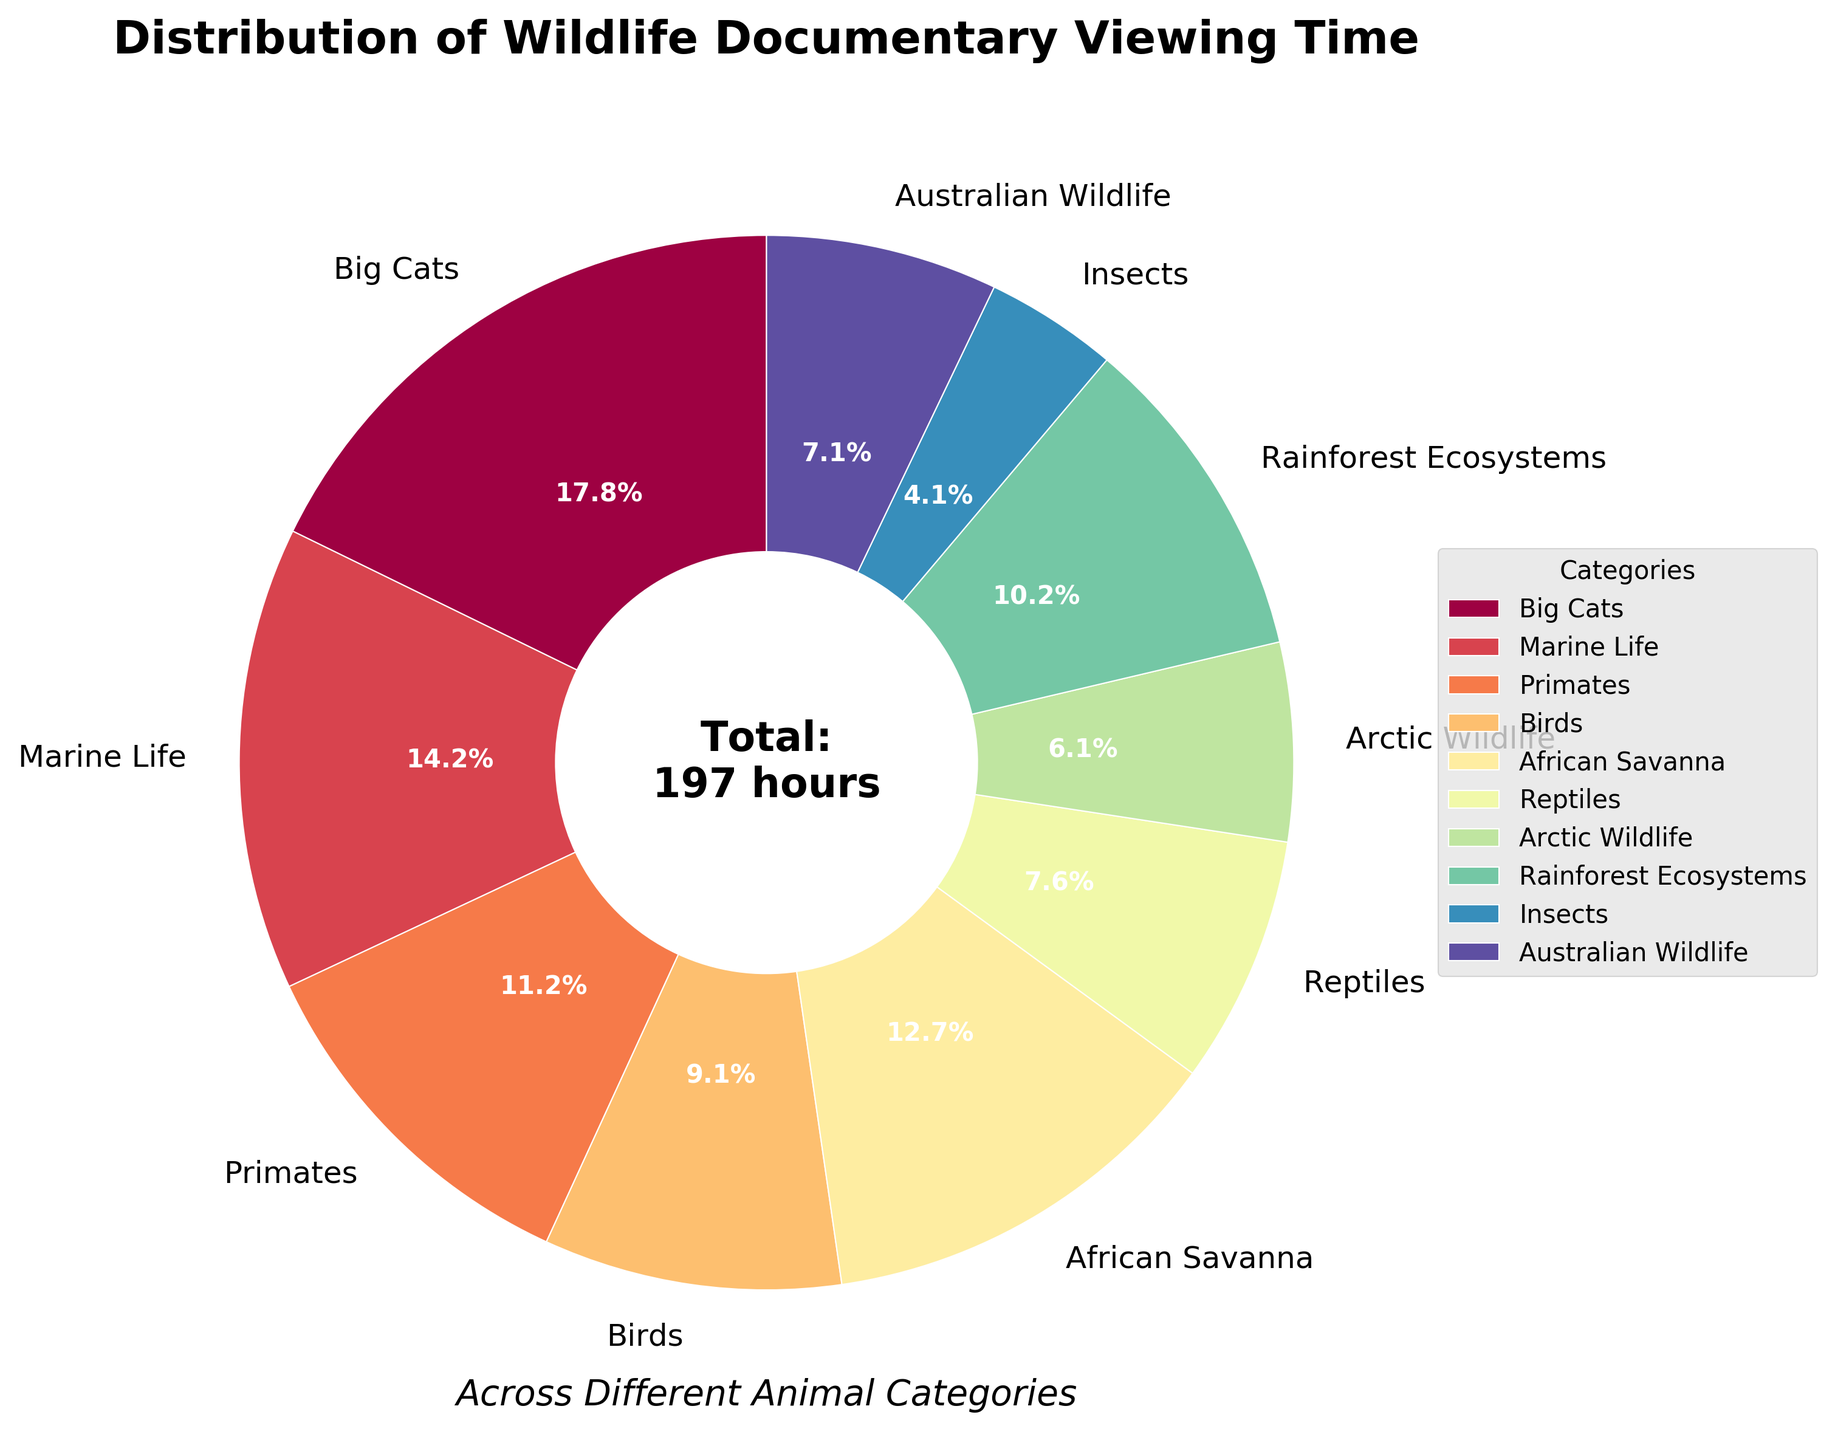Which animal category has the highest viewing time? The largest segment in the pie chart represents the category with the highest viewing time, which is 'Big Cats' with 35 hours.
Answer: Big Cats What percentage of the total viewing time is dedicated to Marine Life? The segment labeled 'Marine Life' shows a percentage value directly on the pie chart, which is 20.0%.
Answer: 20.0% Compare the viewing times for Rainforest Ecosystems and Australian Wildlife. Which one has more hours? By looking at the segments labeled 'Rainforest Ecosystems' and 'Australian Wildlife', we see that Rainforest Ecosystems has 20 hours, and Australian Wildlife has 14 hours. So, Rainforest Ecosystems has more hours.
Answer: Rainforest Ecosystems What is the difference in viewing time between Birds and Arctic Wildlife categories? The pie chart shows Birds with 18 hours and Arctic Wildlife with 12 hours. The difference is calculated as 18 - 12.
Answer: 6 hours How many total hours are spent watching documentaries on African Savanna and Reptiles combined? The pie chart shows African Savanna with 25 hours and Reptiles with 15 hours. Adding these together gives 25 + 15.
Answer: 40 hours Among Primates, Birds, and Insects, which category has the least viewing time? By comparing the segments for Primates (22 hours), Birds (18 hours), and Insects (8 hours), it is evident that Insects have the least viewing time.
Answer: Insects How does the viewing time for Big Cats compare to the combined total of Arctic Wildlife and Insects? Big Cats have 35 hours. Arctic Wildlife has 12 hours and Insects have 8 hours. Combined, Arctic Wildlife and Insects have 12 + 8 = 20 hours. Therefore, Big Cats have more viewing time.
Answer: Big Cats What proportion of the total viewing time is spent on Reptiles? The percentage for Reptiles is shown directly on the pie chart, which is 10.7%.
Answer: 10.7% If we combine the viewing times of Marine Life and African Savanna, what percentage of the total would this combined time represent? Marine Life has 28 hours and African Savanna has 25 hours. Combining these gives 28 + 25 = 53 hours. To find the percentage: (53 / 197) x 100 ≈ 26.9%.
Answer: 26.9% Is the viewing time for Australian Wildlife greater than Rainforest Ecosystems? Checking the segments labeled 'Australian Wildlife' (14 hours) and 'Rainforest Ecosystems' (20 hours), we see that Australian Wildlife has less viewing time.
Answer: No 